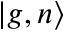<formula> <loc_0><loc_0><loc_500><loc_500>\left | g , n \right \rangle</formula> 